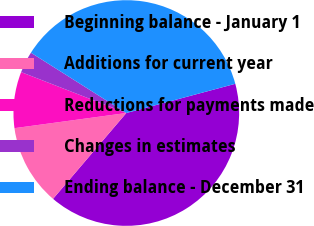<chart> <loc_0><loc_0><loc_500><loc_500><pie_chart><fcel>Beginning balance - January 1<fcel>Additions for current year<fcel>Reductions for payments made<fcel>Changes in estimates<fcel>Ending balance - December 31<nl><fcel>40.41%<fcel>11.61%<fcel>8.05%<fcel>3.07%<fcel>36.85%<nl></chart> 